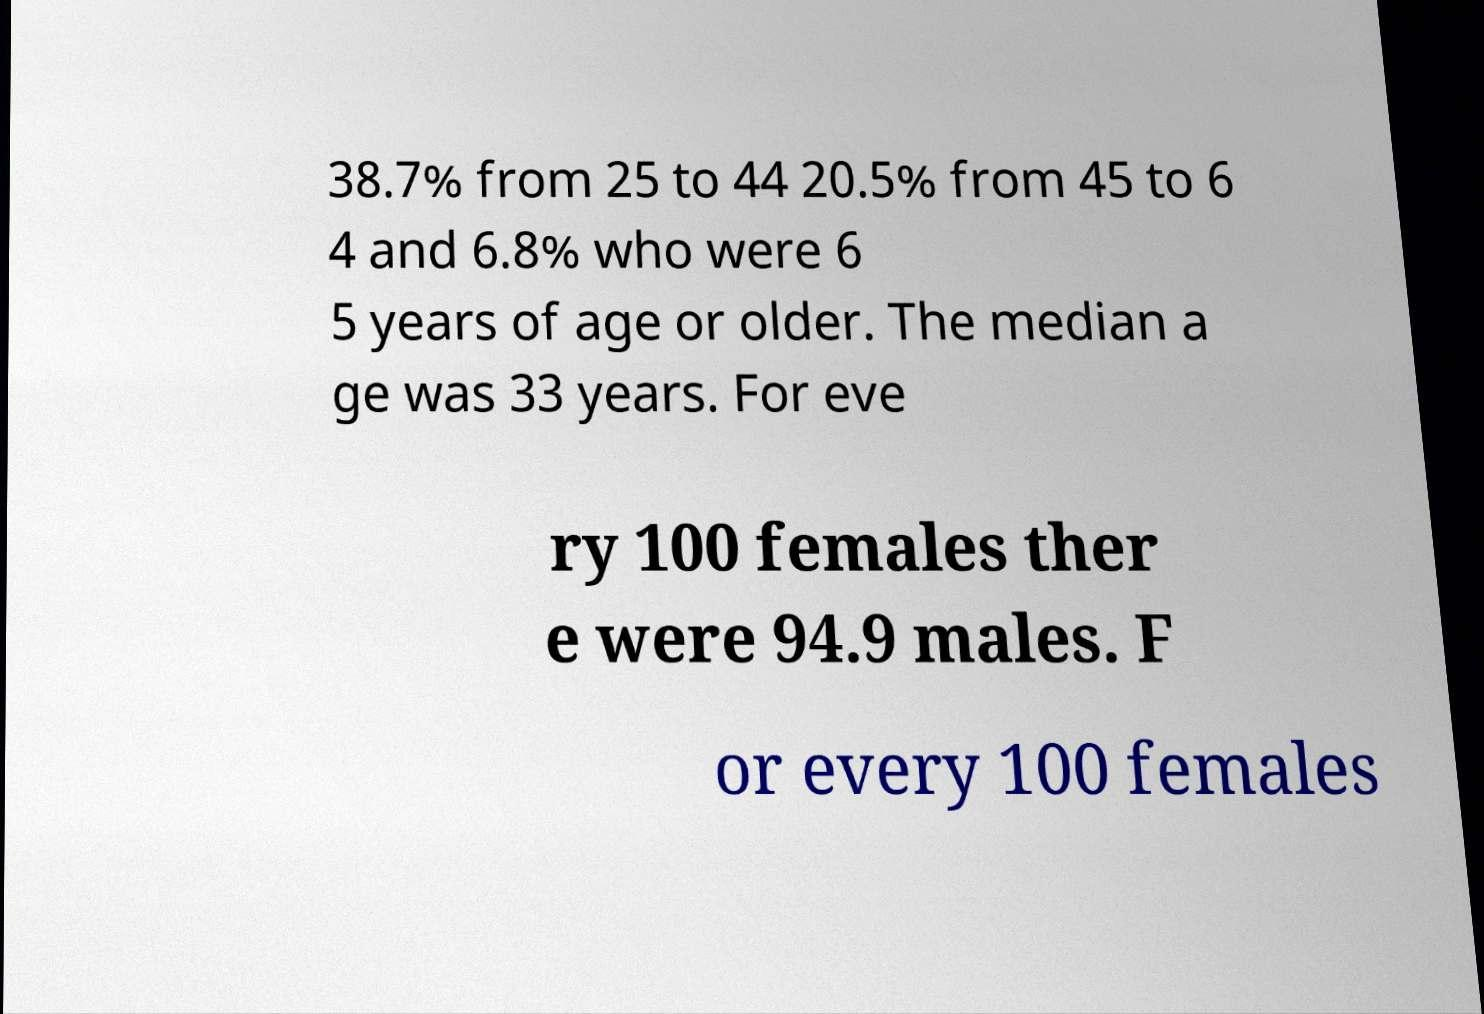Could you extract and type out the text from this image? 38.7% from 25 to 44 20.5% from 45 to 6 4 and 6.8% who were 6 5 years of age or older. The median a ge was 33 years. For eve ry 100 females ther e were 94.9 males. F or every 100 females 